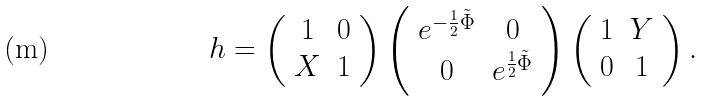<formula> <loc_0><loc_0><loc_500><loc_500>h = \left ( \begin{array} { c c } 1 & 0 \\ X & 1 \end{array} \right ) \left ( \begin{array} { c c } e ^ { - \frac { 1 } { 2 } \tilde { \Phi } } & 0 \\ 0 & e ^ { \frac { 1 } { 2 } \tilde { \Phi } } \end{array} \right ) \left ( \begin{array} { c c } 1 & Y \\ 0 & 1 \end{array} \right ) .</formula> 